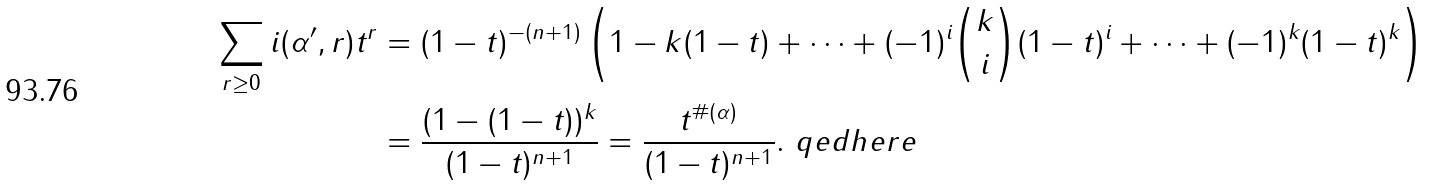<formula> <loc_0><loc_0><loc_500><loc_500>\sum _ { r \geq 0 } i ( \mathcal { \alpha ^ { \prime } } , r ) t ^ { r } & = ( 1 - t ) ^ { - ( n + 1 ) } \left ( 1 - k ( 1 - t ) + \dots + ( - 1 ) ^ { i } \binom { k } { i } ( 1 - t ) ^ { i } + \dots + ( - 1 ) ^ { k } ( 1 - t ) ^ { k } \right ) \\ & = \frac { ( 1 - ( 1 - t ) ) ^ { k } } { ( 1 - t ) ^ { n + 1 } } = \frac { t ^ { \# ( \alpha ) } } { ( 1 - t ) ^ { n + 1 } } . \ q e d h e r e</formula> 